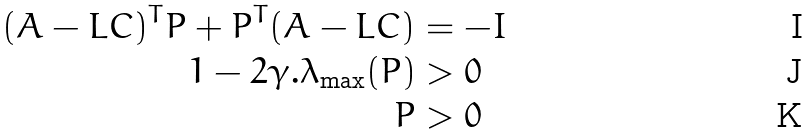<formula> <loc_0><loc_0><loc_500><loc_500>( A - L C ) ^ { T } P + P ^ { T } ( A - L C ) & = - I \\ 1 - 2 \gamma . \lambda _ { \max } ( P ) & > 0 \\ P & > 0</formula> 